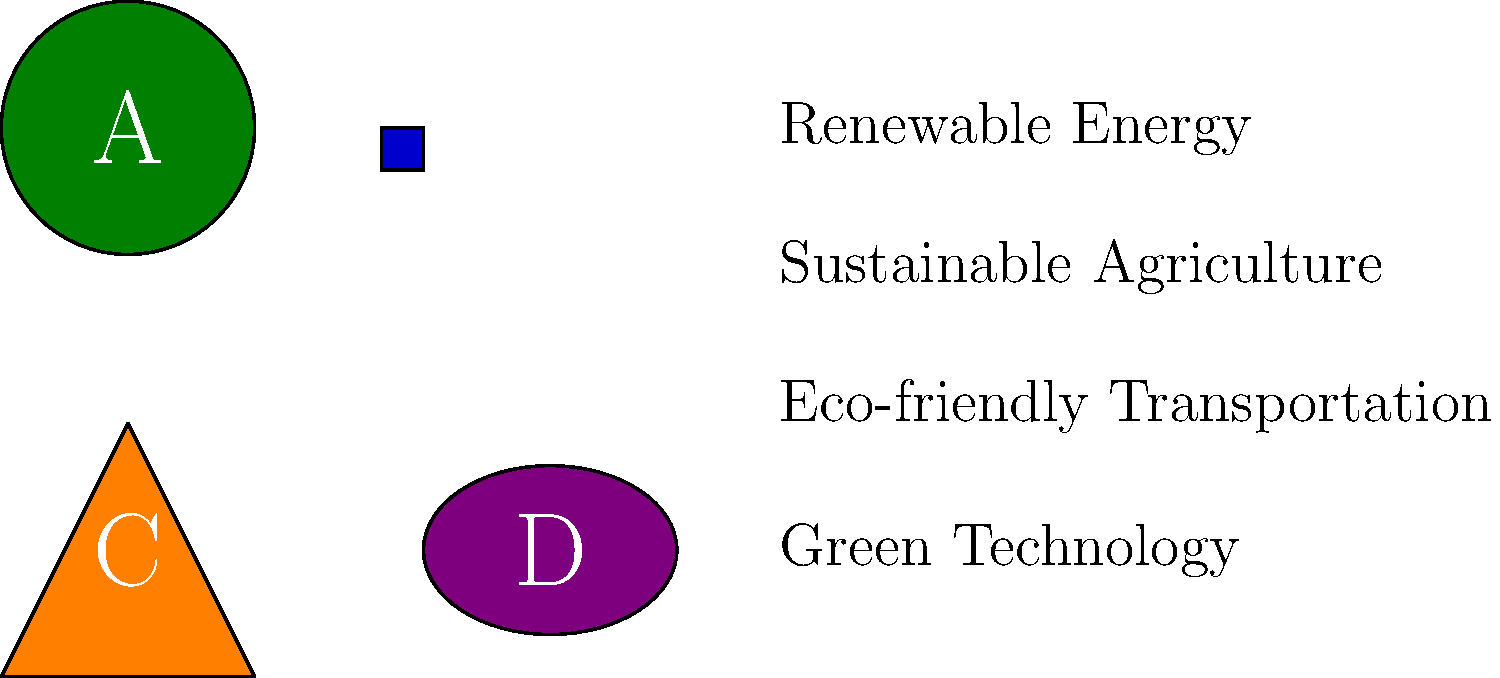Match the sustainable business logos (A, B, C, D) to their corresponding industries. Which logo represents the Eco-friendly Transportation industry? To solve this puzzle, we need to analyze the shapes and colors of the logos and match them to the most fitting industries:

1. Logo A (Green Circle): The circular shape and green color suggest renewable energy, often associated with cyclical processes and nature. This likely represents the Renewable Energy industry.

2. Logo B (Blue Square): The square shape implies stability and structure, while the blue color is often associated with technology. This logo likely represents the Green Technology industry.

3. Logo C (Orange Triangle): The triangle shape resembles an arrow or direction indicator, and the orange color suggests movement or energy. This is the most fitting representation for the Eco-friendly Transportation industry.

4. Logo D (Purple Ellipse): The elliptical shape could represent a leaf or plant, and the purple color is often associated with organic or natural products. This logo best fits the Sustainable Agriculture industry.

Based on this analysis, Logo C (Orange Triangle) represents the Eco-friendly Transportation industry.
Answer: C 